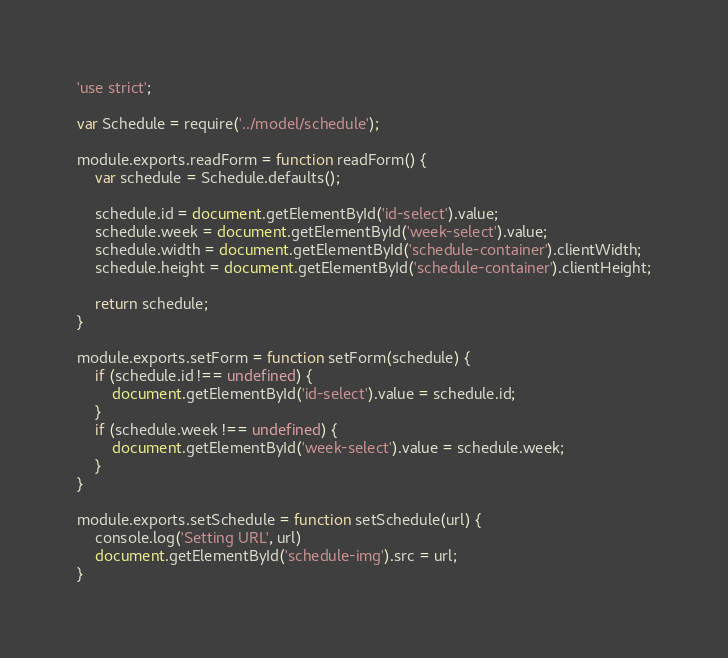<code> <loc_0><loc_0><loc_500><loc_500><_JavaScript_>'use strict';

var Schedule = require('../model/schedule');

module.exports.readForm = function readForm() {
    var schedule = Schedule.defaults();

    schedule.id = document.getElementById('id-select').value;
    schedule.week = document.getElementById('week-select').value;
    schedule.width = document.getElementById('schedule-container').clientWidth;
    schedule.height = document.getElementById('schedule-container').clientHeight;

    return schedule;
}

module.exports.setForm = function setForm(schedule) {
    if (schedule.id !== undefined) {
        document.getElementById('id-select').value = schedule.id;
    }
    if (schedule.week !== undefined) {
        document.getElementById('week-select').value = schedule.week;
    }
}

module.exports.setSchedule = function setSchedule(url) {
    console.log('Setting URL', url)
    document.getElementById('schedule-img').src = url;
}
</code> 